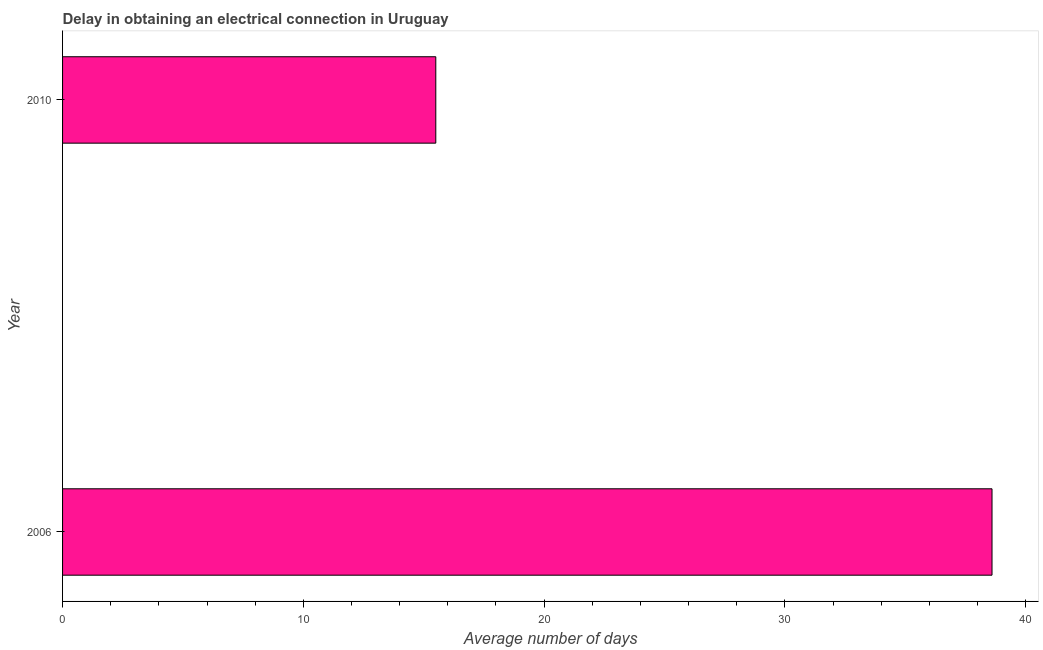Does the graph contain any zero values?
Offer a very short reply. No. Does the graph contain grids?
Offer a very short reply. No. What is the title of the graph?
Your answer should be compact. Delay in obtaining an electrical connection in Uruguay. What is the label or title of the X-axis?
Make the answer very short. Average number of days. What is the dalay in electrical connection in 2006?
Your answer should be compact. 38.6. Across all years, what is the maximum dalay in electrical connection?
Offer a terse response. 38.6. In which year was the dalay in electrical connection maximum?
Your response must be concise. 2006. What is the sum of the dalay in electrical connection?
Offer a terse response. 54.1. What is the difference between the dalay in electrical connection in 2006 and 2010?
Offer a terse response. 23.1. What is the average dalay in electrical connection per year?
Offer a terse response. 27.05. What is the median dalay in electrical connection?
Your answer should be compact. 27.05. In how many years, is the dalay in electrical connection greater than 2 days?
Offer a very short reply. 2. What is the ratio of the dalay in electrical connection in 2006 to that in 2010?
Your response must be concise. 2.49. Are all the bars in the graph horizontal?
Ensure brevity in your answer.  Yes. What is the difference between two consecutive major ticks on the X-axis?
Offer a very short reply. 10. Are the values on the major ticks of X-axis written in scientific E-notation?
Give a very brief answer. No. What is the Average number of days in 2006?
Make the answer very short. 38.6. What is the difference between the Average number of days in 2006 and 2010?
Ensure brevity in your answer.  23.1. What is the ratio of the Average number of days in 2006 to that in 2010?
Provide a short and direct response. 2.49. 